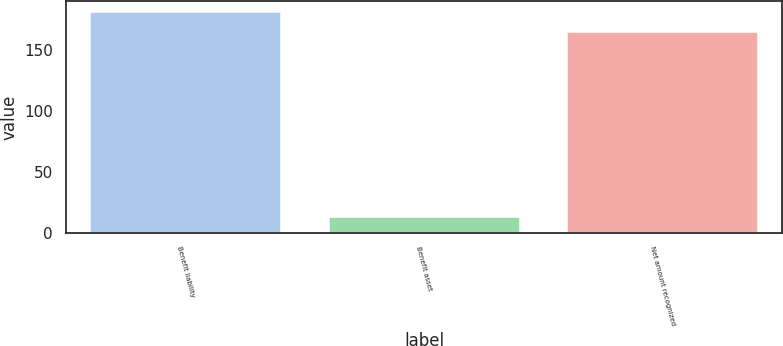<chart> <loc_0><loc_0><loc_500><loc_500><bar_chart><fcel>Benefit liability<fcel>Benefit asset<fcel>Net amount recognized<nl><fcel>181.5<fcel>13<fcel>165<nl></chart> 